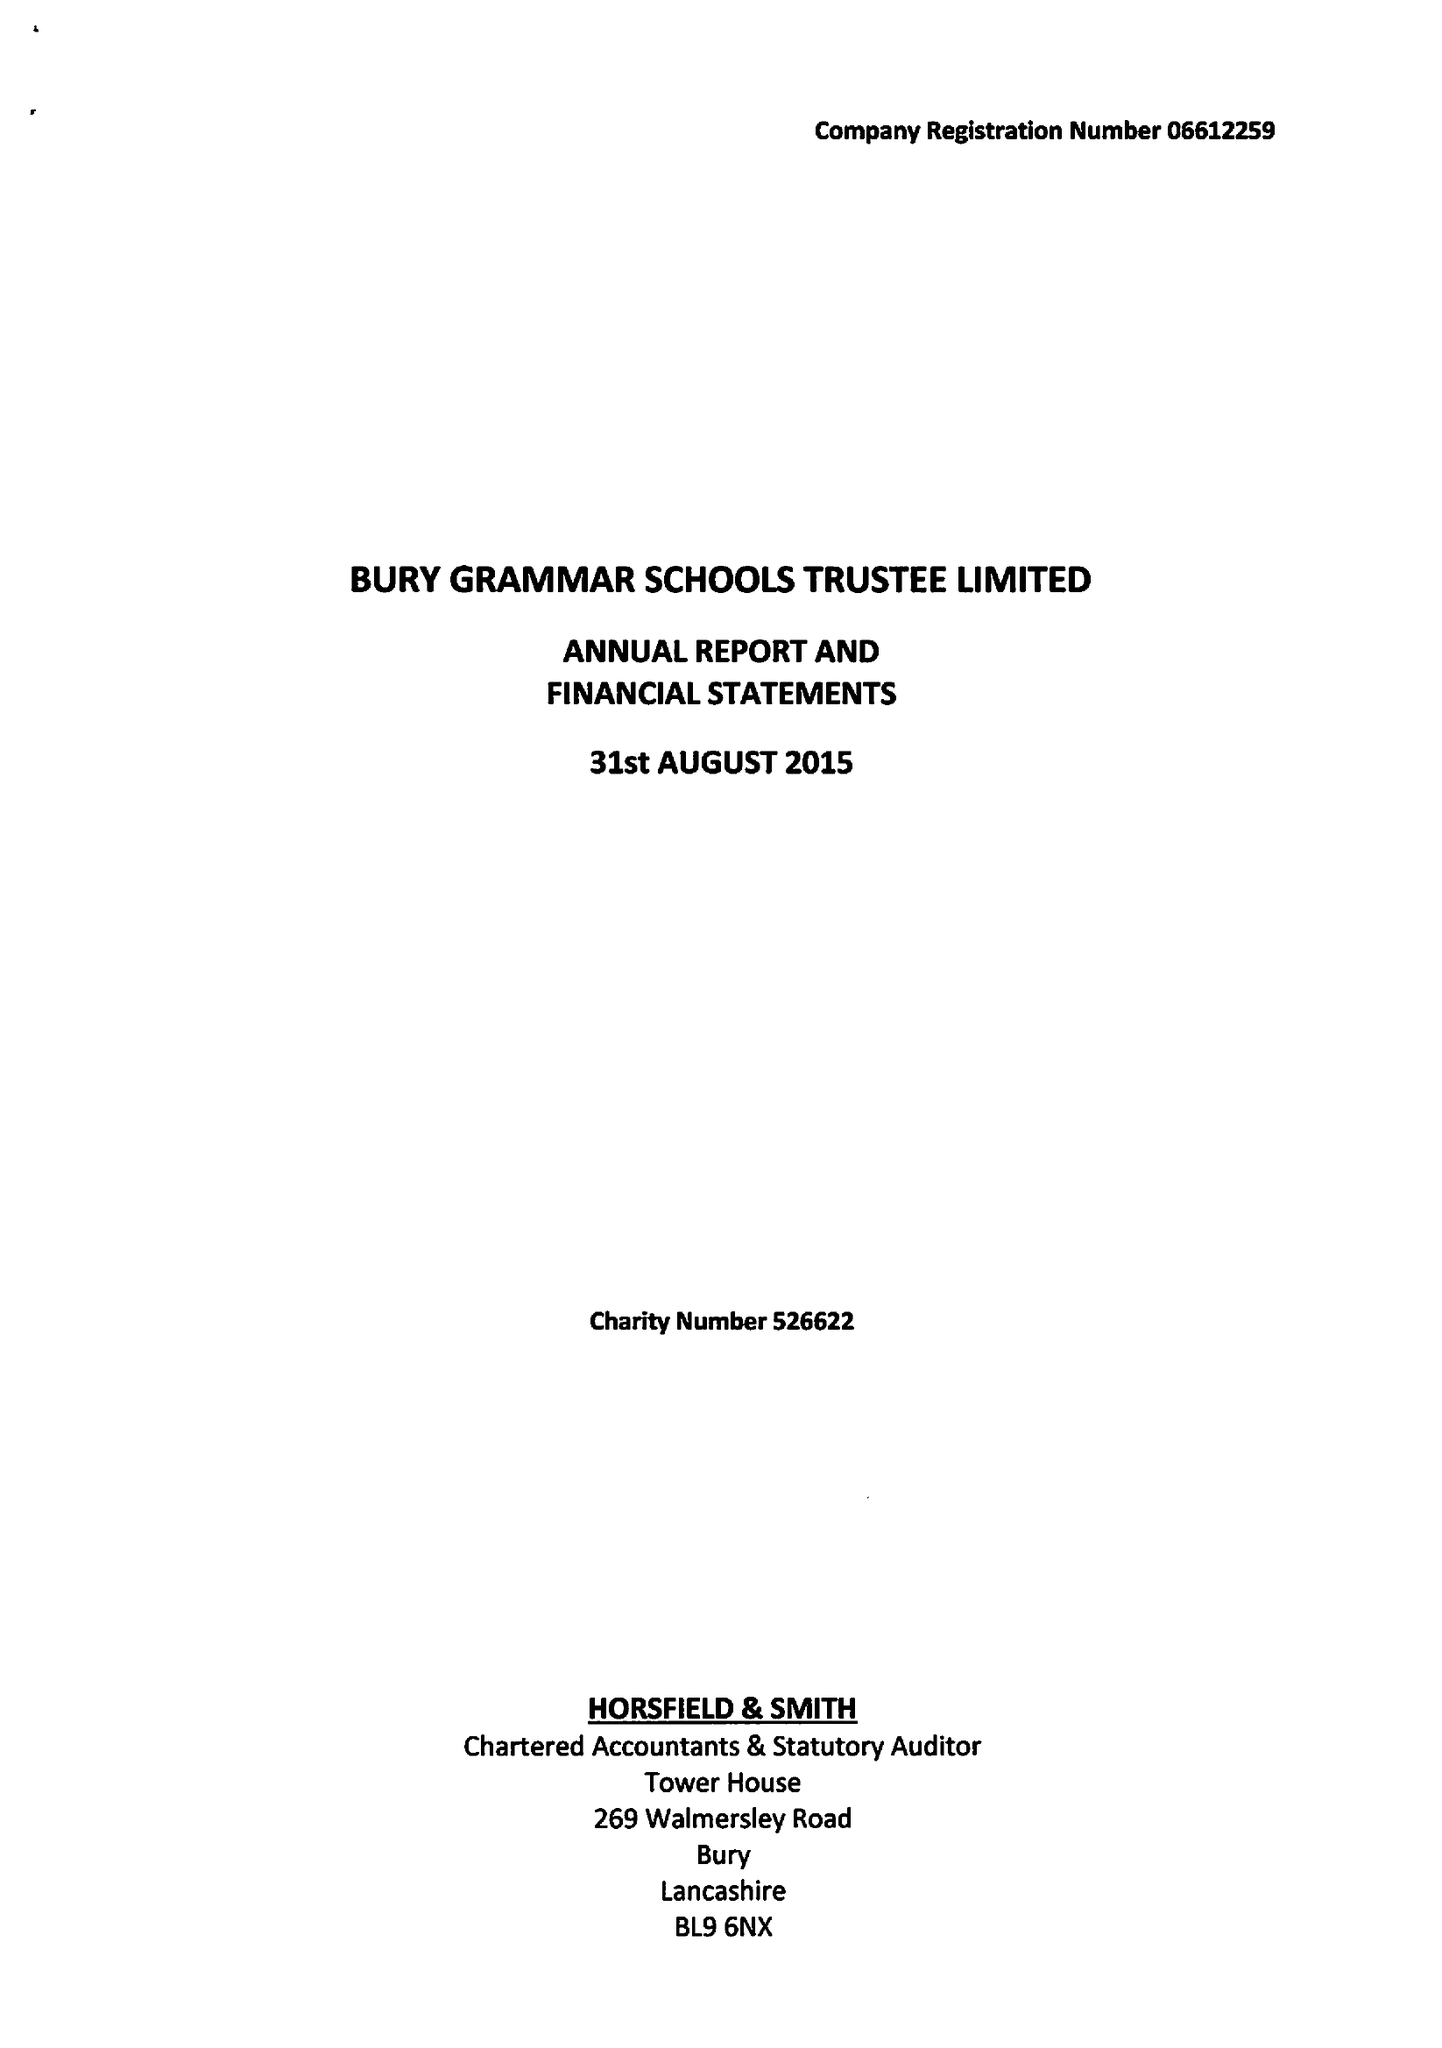What is the value for the report_date?
Answer the question using a single word or phrase. 2015-08-31 